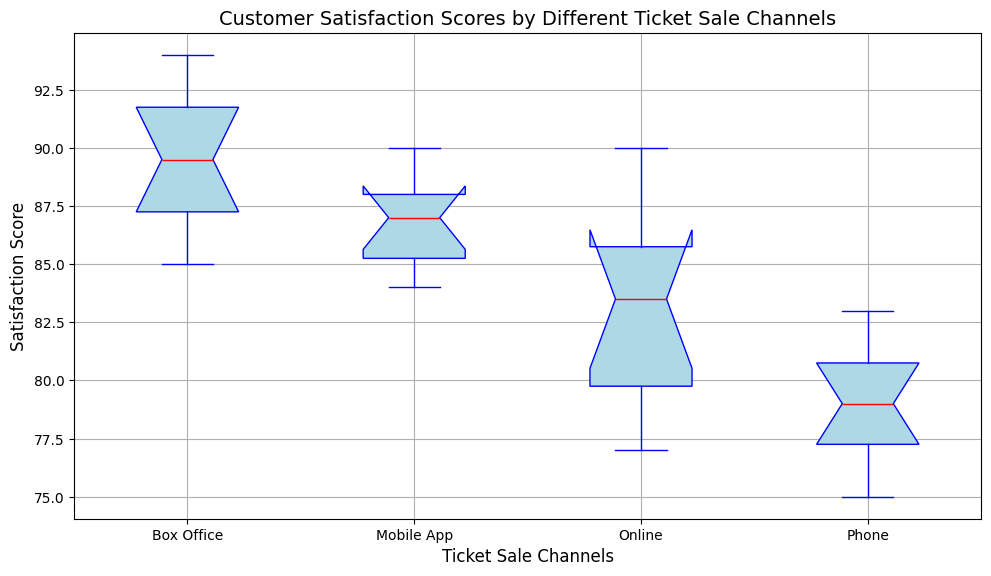Which ticket sale channel has the highest median customer satisfaction score? The Box Office channel's median line, marked in red, is the highest of all channels.
Answer: Box Office What is the range of customer satisfaction scores for the online channel? The range is the difference between the maximum and minimum scores. For the Online channel, the scores range from 77 to 90.
Answer: 13 Which channel has the most tightly clustered satisfaction scores? The Mobile App channel has the shortest box, indicating lower variability and clustering around the median.
Answer: Mobile App How does the interquartile range (IQR) of the Phone channel compare with that of the Online channel? The IQR is the distance between the first and third quartiles. The Phone channel has a slightly taller box compared to the Online channel, indicating a larger IQR.
Answer: Phone has a larger IQR Which channels have their satisfaction scores extending below 80? The whiskers extend below 80 for both the Online and Phone channels.
Answer: Online and Phone Of the Box Office and Phone channels, which has greater overall satisfaction scores? Visually comparing the box plots, Box Office scores are generally higher, extending to higher values than the Phone channel.
Answer: Box Office What is the difference between the median customer satisfaction scores of the Online and Mobile App channels? The median line for Online is at 83, whereas for Mobile App it is at 87. Thus, the difference is 87 - 83 = 4.
Answer: 4 Which channel shows the highest single customer satisfaction score, and what is it? The Box Office channel has the highest satisfaction score, which reaches up to 94.
Answer: Box Office, 94 Which ticket sale channel has the most outliers, and what could this suggest about the customer experience for that channel? The Phone channel has the most outliers, marked by green dots, suggesting more variability in customer satisfaction experiences.
Answer: Phone 